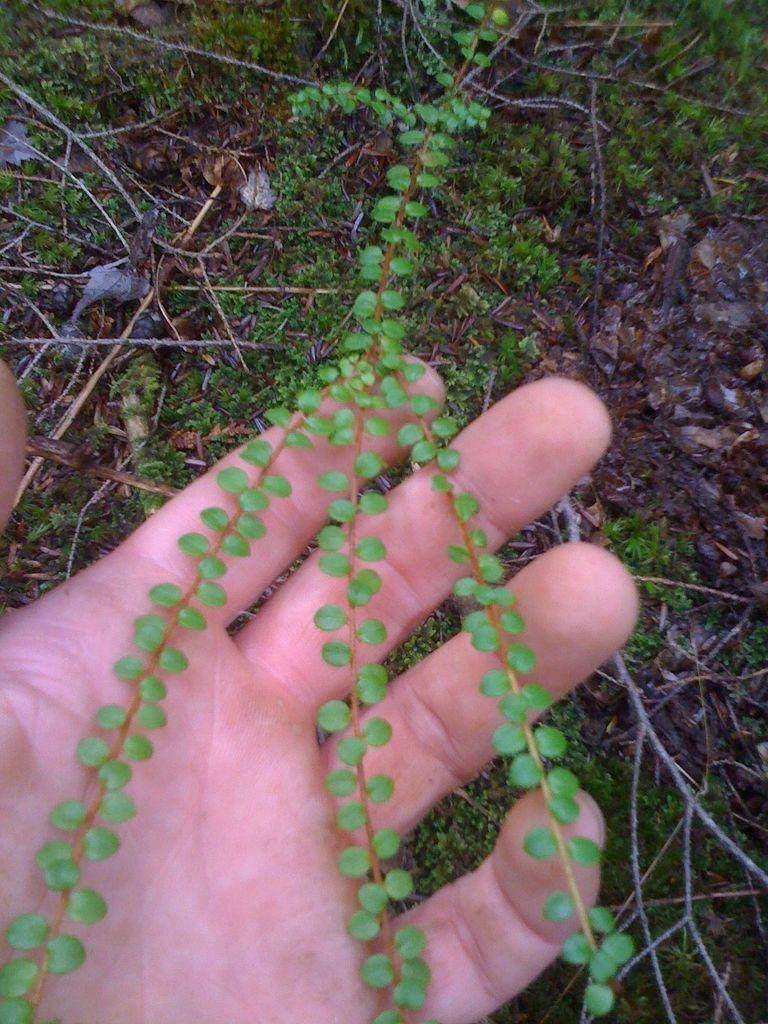What type of plant is visible in the image? There is a grass plant in the image. What is the person's hand doing in relation to the grass plant? A person's hand is touching the grass plant. Are there any other plants visible in the image? Yes, there are plant saplings in the image. What type of cheese is being offered to the horse in the image? There is no cheese or horse present in the image; it only features a grass plant and plant saplings. 